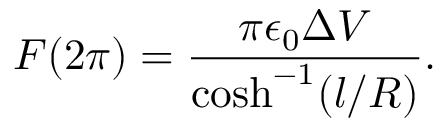Convert formula to latex. <formula><loc_0><loc_0><loc_500><loc_500>F ( 2 \pi ) = \frac { \pi \epsilon _ { 0 } \Delta V } { \cosh ^ { - 1 } ( l / R ) } .</formula> 